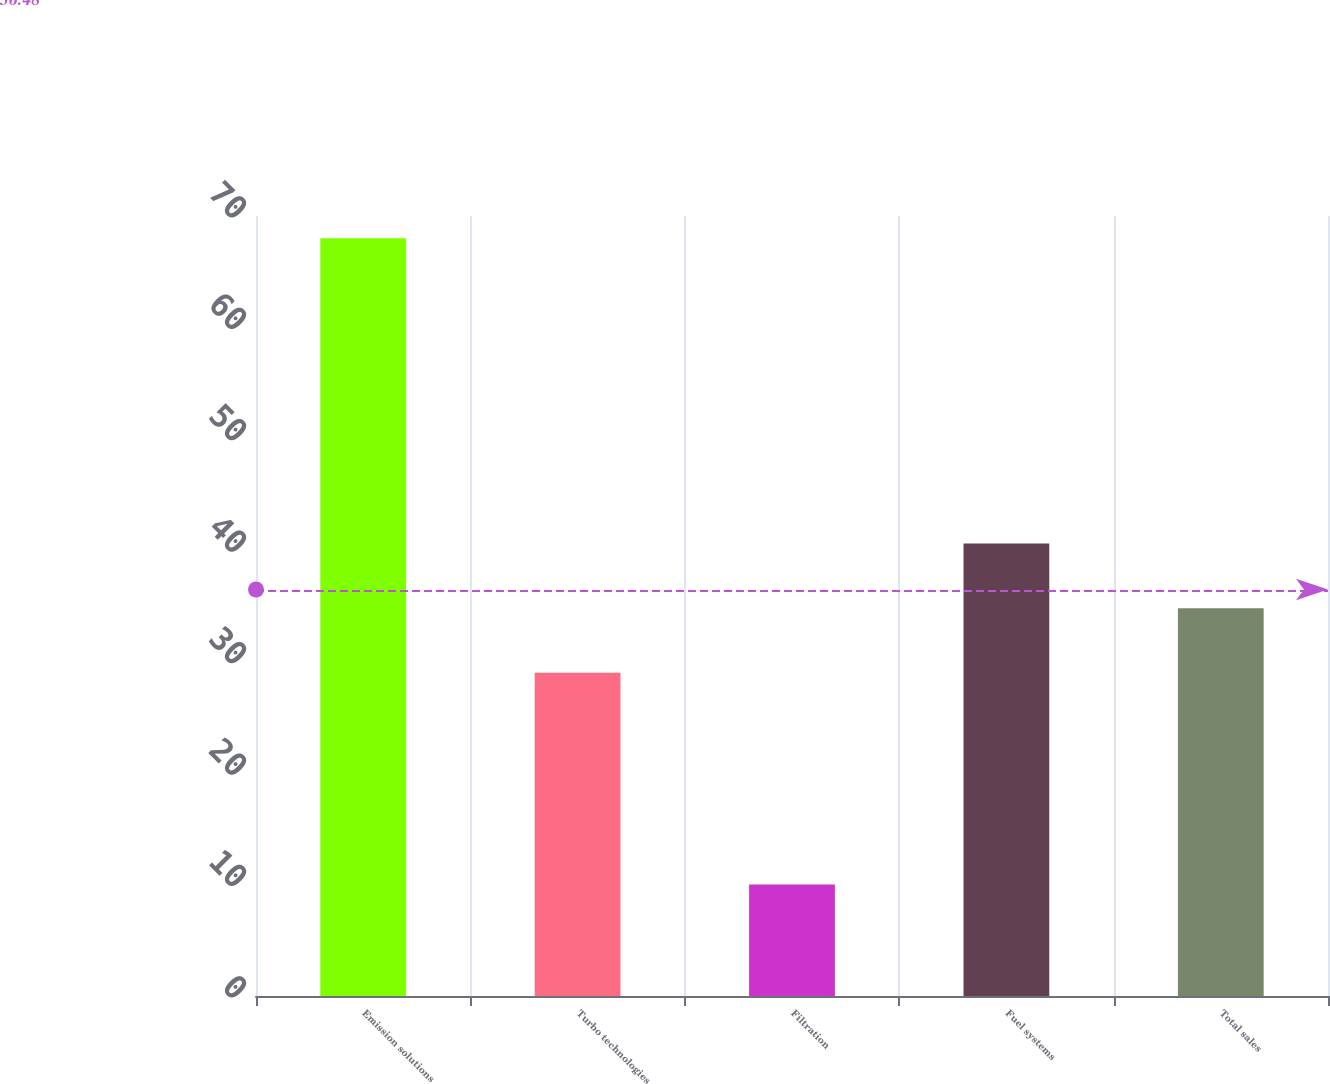Convert chart to OTSL. <chart><loc_0><loc_0><loc_500><loc_500><bar_chart><fcel>Emission solutions<fcel>Turbo technologies<fcel>Filtration<fcel>Fuel systems<fcel>Total sales<nl><fcel>68<fcel>29<fcel>10<fcel>40.6<fcel>34.8<nl></chart> 